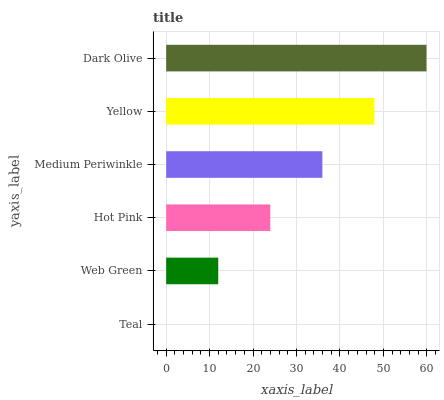Is Teal the minimum?
Answer yes or no. Yes. Is Dark Olive the maximum?
Answer yes or no. Yes. Is Web Green the minimum?
Answer yes or no. No. Is Web Green the maximum?
Answer yes or no. No. Is Web Green greater than Teal?
Answer yes or no. Yes. Is Teal less than Web Green?
Answer yes or no. Yes. Is Teal greater than Web Green?
Answer yes or no. No. Is Web Green less than Teal?
Answer yes or no. No. Is Medium Periwinkle the high median?
Answer yes or no. Yes. Is Hot Pink the low median?
Answer yes or no. Yes. Is Dark Olive the high median?
Answer yes or no. No. Is Teal the low median?
Answer yes or no. No. 